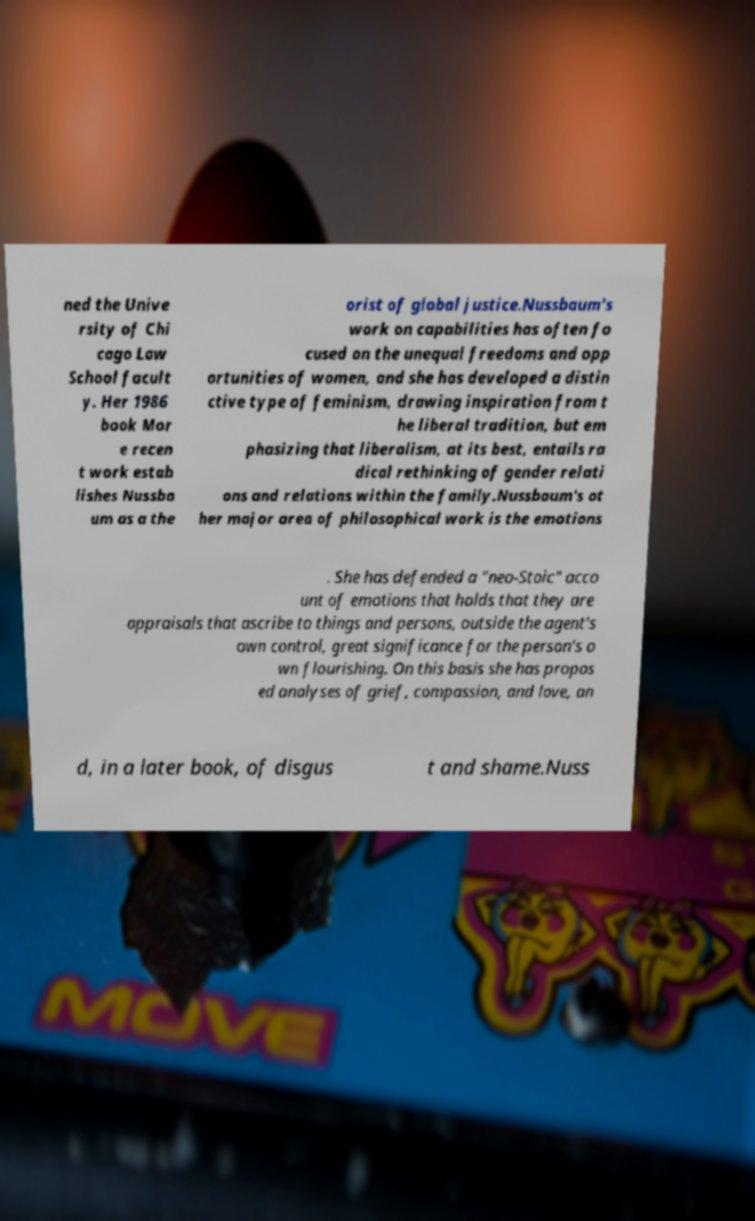Please read and relay the text visible in this image. What does it say? ned the Unive rsity of Chi cago Law School facult y. Her 1986 book Mor e recen t work estab lishes Nussba um as a the orist of global justice.Nussbaum's work on capabilities has often fo cused on the unequal freedoms and opp ortunities of women, and she has developed a distin ctive type of feminism, drawing inspiration from t he liberal tradition, but em phasizing that liberalism, at its best, entails ra dical rethinking of gender relati ons and relations within the family.Nussbaum's ot her major area of philosophical work is the emotions . She has defended a "neo-Stoic" acco unt of emotions that holds that they are appraisals that ascribe to things and persons, outside the agent's own control, great significance for the person's o wn flourishing. On this basis she has propos ed analyses of grief, compassion, and love, an d, in a later book, of disgus t and shame.Nuss 